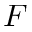Convert formula to latex. <formula><loc_0><loc_0><loc_500><loc_500>F</formula> 